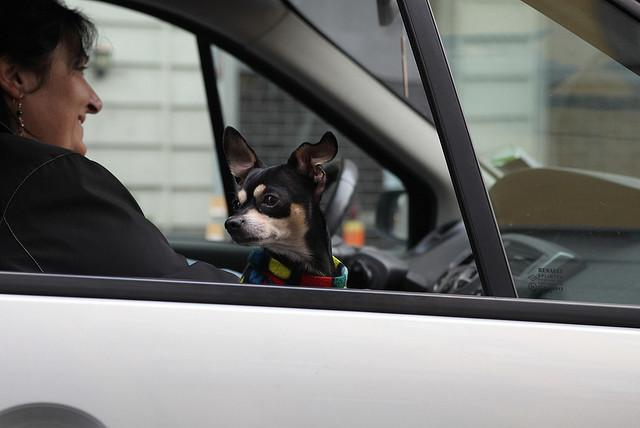What is this dog's owner doing? driving 